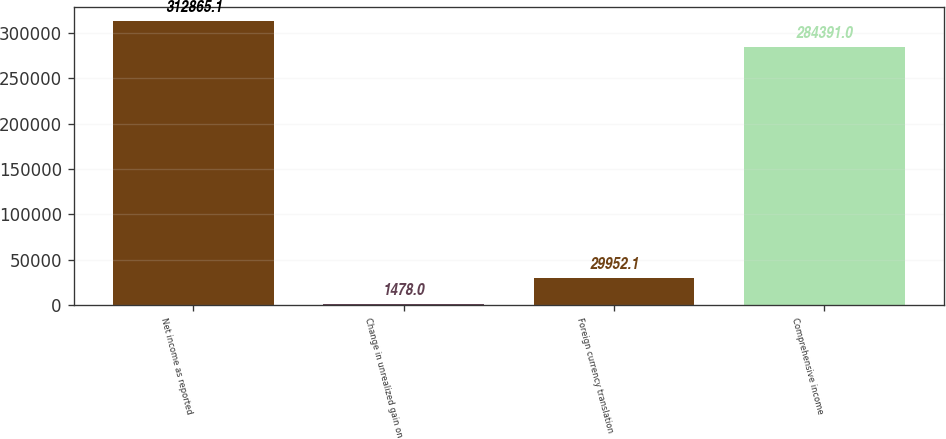Convert chart to OTSL. <chart><loc_0><loc_0><loc_500><loc_500><bar_chart><fcel>Net income as reported<fcel>Change in unrealized gain on<fcel>Foreign currency translation<fcel>Comprehensive income<nl><fcel>312865<fcel>1478<fcel>29952.1<fcel>284391<nl></chart> 